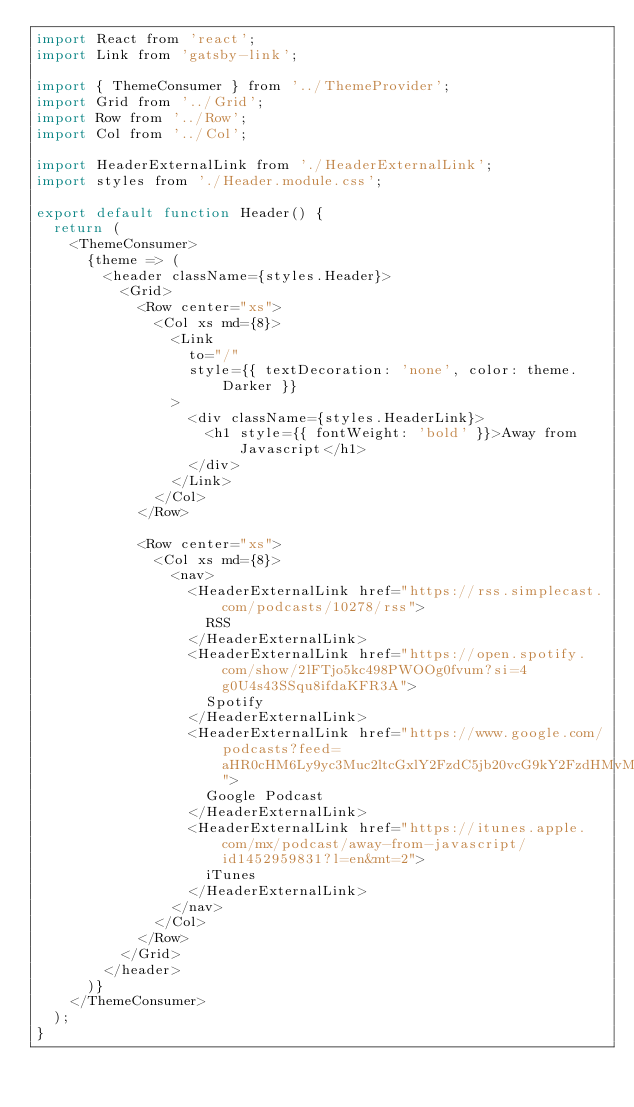<code> <loc_0><loc_0><loc_500><loc_500><_JavaScript_>import React from 'react';
import Link from 'gatsby-link';

import { ThemeConsumer } from '../ThemeProvider';
import Grid from '../Grid';
import Row from '../Row';
import Col from '../Col';

import HeaderExternalLink from './HeaderExternalLink';
import styles from './Header.module.css';

export default function Header() {
  return (
    <ThemeConsumer>
      {theme => (
        <header className={styles.Header}>
          <Grid>
            <Row center="xs">
              <Col xs md={8}>
                <Link
                  to="/"
                  style={{ textDecoration: 'none', color: theme.Darker }}
                >
                  <div className={styles.HeaderLink}>
                    <h1 style={{ fontWeight: 'bold' }}>Away from Javascript</h1>
                  </div>
                </Link>
              </Col>
            </Row>

            <Row center="xs">
              <Col xs md={8}>
                <nav>
                  <HeaderExternalLink href="https://rss.simplecast.com/podcasts/10278/rss">
                    RSS
                  </HeaderExternalLink>
                  <HeaderExternalLink href="https://open.spotify.com/show/2lFTjo5kc498PWOOg0fvum?si=4g0U4s43SSqu8ifdaKFR3A">
                    Spotify
                  </HeaderExternalLink>
                  <HeaderExternalLink href="https://www.google.com/podcasts?feed=aHR0cHM6Ly9yc3Muc2ltcGxlY2FzdC5jb20vcG9kY2FzdHMvMTAyNzgvcnNz">
                    Google Podcast
                  </HeaderExternalLink>
                  <HeaderExternalLink href="https://itunes.apple.com/mx/podcast/away-from-javascript/id1452959831?l=en&mt=2">
                    iTunes
                  </HeaderExternalLink>
                </nav>
              </Col>
            </Row>
          </Grid>
        </header>
      )}
    </ThemeConsumer>
  );
}
</code> 